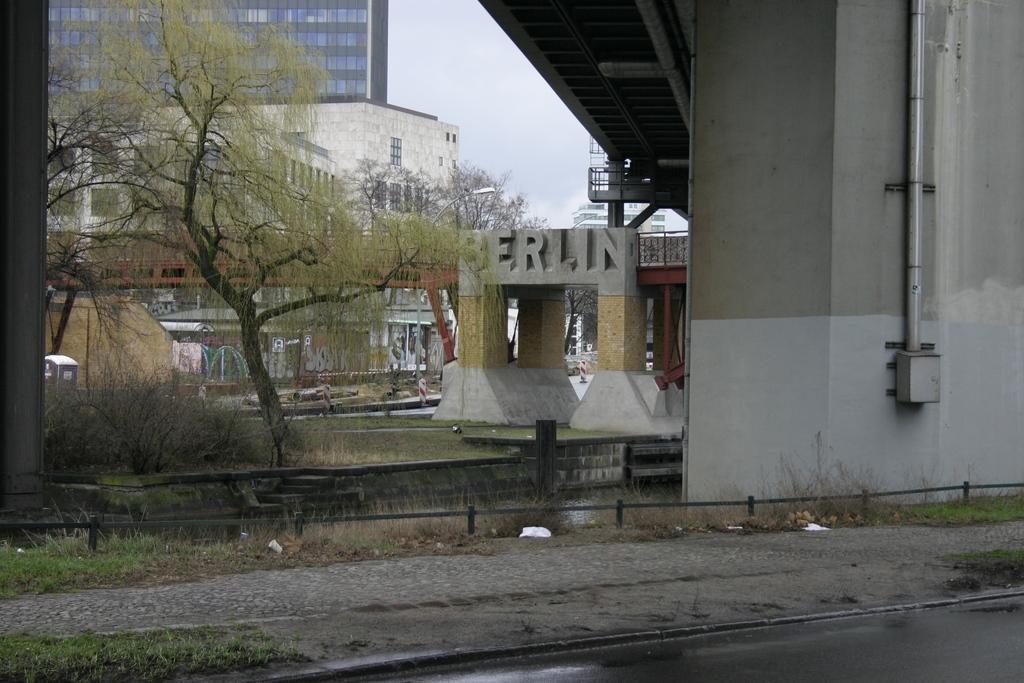Could you give a brief overview of what you see in this image? This image is taken outdoors. At the bottom of the image there is a ground with grass on it. There is a floor. At the top of the image there is the sky with clouds and there is a bridge with walls and pillars. On the right side of the image there is a wall and there is a pipeline. On the left side of the image there are a few buildings. There are a few trees and plants with leaves, stems and branches. There are a few objects. There is a pole. In the middle of the image there are a few pillars and there is a text on the wall. 